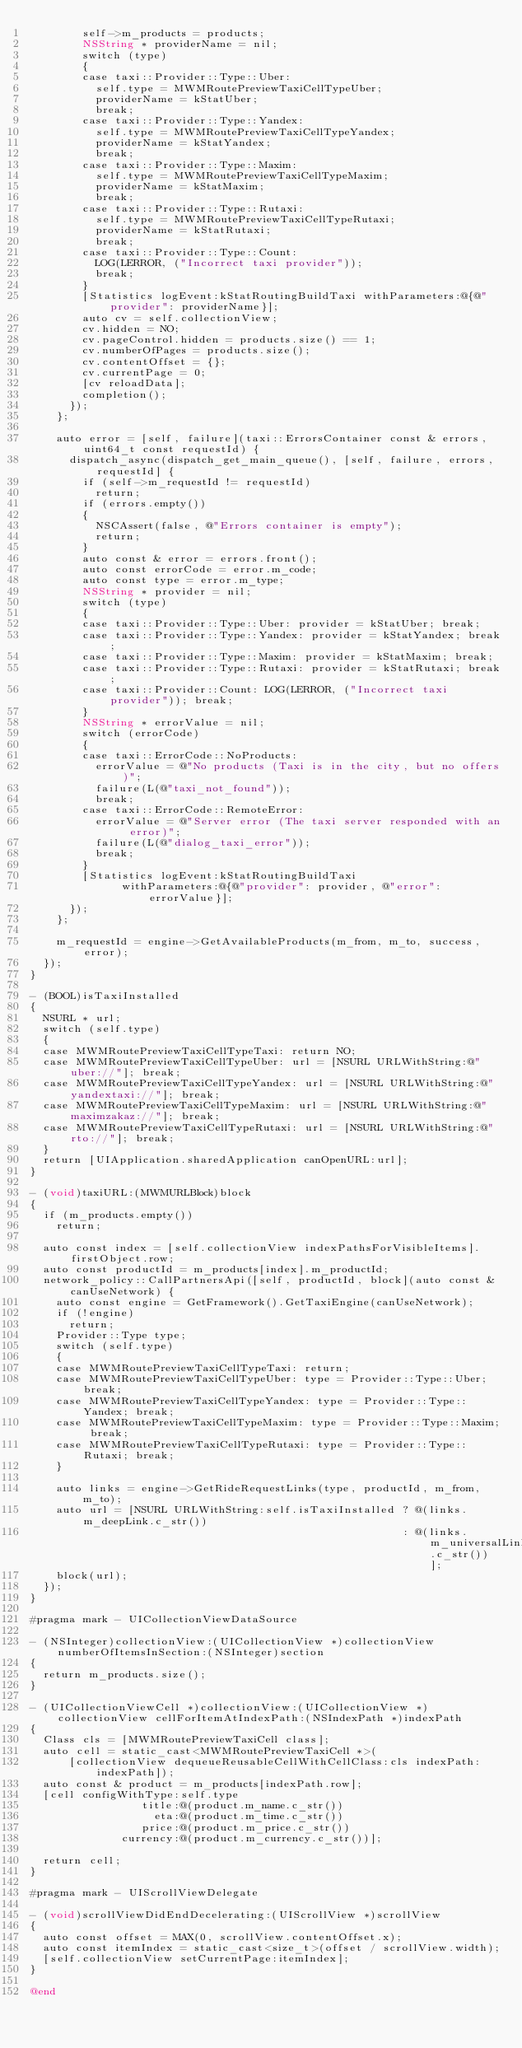Convert code to text. <code><loc_0><loc_0><loc_500><loc_500><_ObjectiveC_>        self->m_products = products;
        NSString * providerName = nil;
        switch (type)
        {
        case taxi::Provider::Type::Uber:
          self.type = MWMRoutePreviewTaxiCellTypeUber;
          providerName = kStatUber;
          break;
        case taxi::Provider::Type::Yandex:
          self.type = MWMRoutePreviewTaxiCellTypeYandex;
          providerName = kStatYandex;
          break;
        case taxi::Provider::Type::Maxim:
          self.type = MWMRoutePreviewTaxiCellTypeMaxim;
          providerName = kStatMaxim;
          break;
        case taxi::Provider::Type::Rutaxi:
          self.type = MWMRoutePreviewTaxiCellTypeRutaxi;
          providerName = kStatRutaxi;
          break;
        case taxi::Provider::Type::Count:
          LOG(LERROR, ("Incorrect taxi provider"));
          break;
        }
        [Statistics logEvent:kStatRoutingBuildTaxi withParameters:@{@"provider": providerName}];
        auto cv = self.collectionView;
        cv.hidden = NO;
        cv.pageControl.hidden = products.size() == 1;
        cv.numberOfPages = products.size();
        cv.contentOffset = {};
        cv.currentPage = 0;
        [cv reloadData];
        completion();
      });
    };

    auto error = [self, failure](taxi::ErrorsContainer const & errors, uint64_t const requestId) {
      dispatch_async(dispatch_get_main_queue(), [self, failure, errors, requestId] {
        if (self->m_requestId != requestId)
          return;
        if (errors.empty())
        {
          NSCAssert(false, @"Errors container is empty");
          return;
        }
        auto const & error = errors.front();
        auto const errorCode = error.m_code;
        auto const type = error.m_type;
        NSString * provider = nil;
        switch (type)
        {
        case taxi::Provider::Type::Uber: provider = kStatUber; break;
        case taxi::Provider::Type::Yandex: provider = kStatYandex; break;
        case taxi::Provider::Type::Maxim: provider = kStatMaxim; break;
        case taxi::Provider::Type::Rutaxi: provider = kStatRutaxi; break;
        case taxi::Provider::Count: LOG(LERROR, ("Incorrect taxi provider")); break;
        }
        NSString * errorValue = nil;
        switch (errorCode)
        {
        case taxi::ErrorCode::NoProducts:
          errorValue = @"No products (Taxi is in the city, but no offers)";
          failure(L(@"taxi_not_found"));
          break;
        case taxi::ErrorCode::RemoteError:
          errorValue = @"Server error (The taxi server responded with an error)";
          failure(L(@"dialog_taxi_error"));
          break;
        }
        [Statistics logEvent:kStatRoutingBuildTaxi
              withParameters:@{@"provider": provider, @"error": errorValue}];
      });
    };

    m_requestId = engine->GetAvailableProducts(m_from, m_to, success, error);
  });
}

- (BOOL)isTaxiInstalled
{
  NSURL * url;
  switch (self.type)
  {
  case MWMRoutePreviewTaxiCellTypeTaxi: return NO;
  case MWMRoutePreviewTaxiCellTypeUber: url = [NSURL URLWithString:@"uber://"]; break;
  case MWMRoutePreviewTaxiCellTypeYandex: url = [NSURL URLWithString:@"yandextaxi://"]; break;
  case MWMRoutePreviewTaxiCellTypeMaxim: url = [NSURL URLWithString:@"maximzakaz://"]; break;
  case MWMRoutePreviewTaxiCellTypeRutaxi: url = [NSURL URLWithString:@"rto://"]; break;
  }
  return [UIApplication.sharedApplication canOpenURL:url];
}

- (void)taxiURL:(MWMURLBlock)block
{
  if (m_products.empty())
    return;

  auto const index = [self.collectionView indexPathsForVisibleItems].firstObject.row;
  auto const productId = m_products[index].m_productId;
  network_policy::CallPartnersApi([self, productId, block](auto const & canUseNetwork) {
    auto const engine = GetFramework().GetTaxiEngine(canUseNetwork);
    if (!engine)
      return;
    Provider::Type type;
    switch (self.type)
    {
    case MWMRoutePreviewTaxiCellTypeTaxi: return;
    case MWMRoutePreviewTaxiCellTypeUber: type = Provider::Type::Uber; break;
    case MWMRoutePreviewTaxiCellTypeYandex: type = Provider::Type::Yandex; break;
    case MWMRoutePreviewTaxiCellTypeMaxim: type = Provider::Type::Maxim; break;
    case MWMRoutePreviewTaxiCellTypeRutaxi: type = Provider::Type::Rutaxi; break;
    }

    auto links = engine->GetRideRequestLinks(type, productId, m_from, m_to);
    auto url = [NSURL URLWithString:self.isTaxiInstalled ? @(links.m_deepLink.c_str())
                                                         : @(links.m_universalLink.c_str())];
    block(url);
  });
}

#pragma mark - UICollectionViewDataSource

- (NSInteger)collectionView:(UICollectionView *)collectionView numberOfItemsInSection:(NSInteger)section
{
  return m_products.size();
}

- (UICollectionViewCell *)collectionView:(UICollectionView *)collectionView cellForItemAtIndexPath:(NSIndexPath *)indexPath
{
  Class cls = [MWMRoutePreviewTaxiCell class];
  auto cell = static_cast<MWMRoutePreviewTaxiCell *>(
      [collectionView dequeueReusableCellWithCellClass:cls indexPath:indexPath]);
  auto const & product = m_products[indexPath.row];
  [cell configWithType:self.type
                 title:@(product.m_name.c_str())
                   eta:@(product.m_time.c_str())
                 price:@(product.m_price.c_str())
              currency:@(product.m_currency.c_str())];

  return cell;
}

#pragma mark - UIScrollViewDelegate

- (void)scrollViewDidEndDecelerating:(UIScrollView *)scrollView
{
  auto const offset = MAX(0, scrollView.contentOffset.x);
  auto const itemIndex = static_cast<size_t>(offset / scrollView.width);
  [self.collectionView setCurrentPage:itemIndex];
}

@end
</code> 